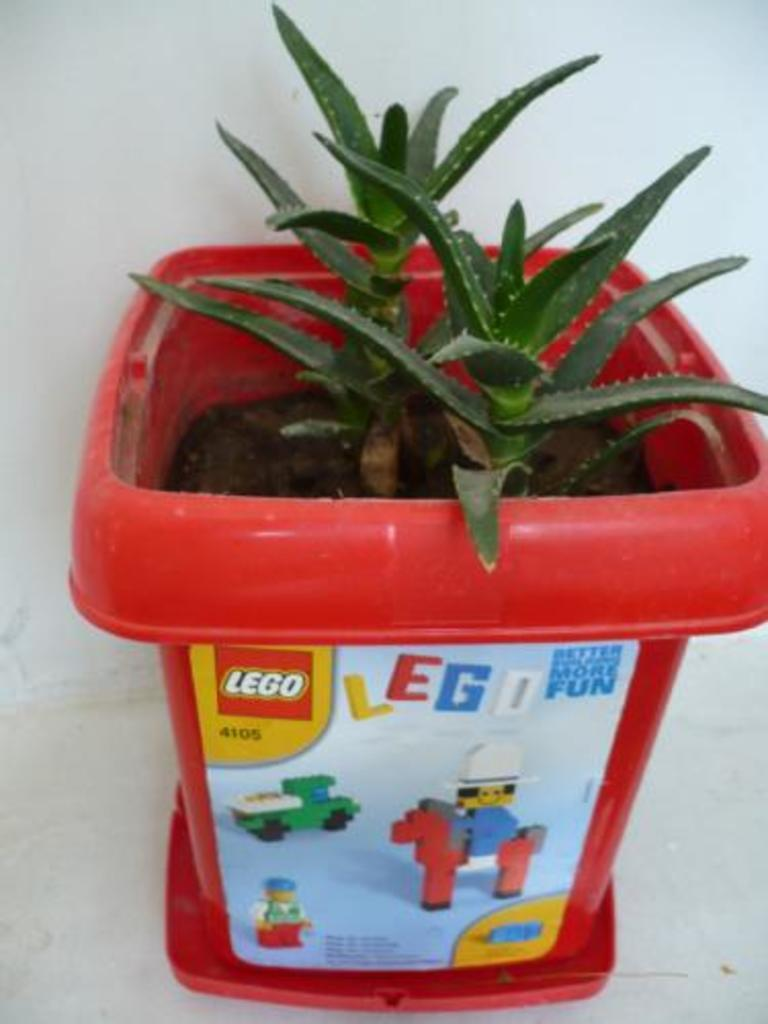What is the main object in the center of the image? There is a flower pot in the center of the image. Where is the flower pot located? The flower pot is on the floor. What can be seen in the background of the image? There is a wall in the background of the image. How many pencils are visible in the image? There are no pencils present in the image. What type of stick can be seen leaning against the wall in the image? There is no stick visible in the image; only the flower pot and wall are present. 